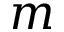Convert formula to latex. <formula><loc_0><loc_0><loc_500><loc_500>m</formula> 